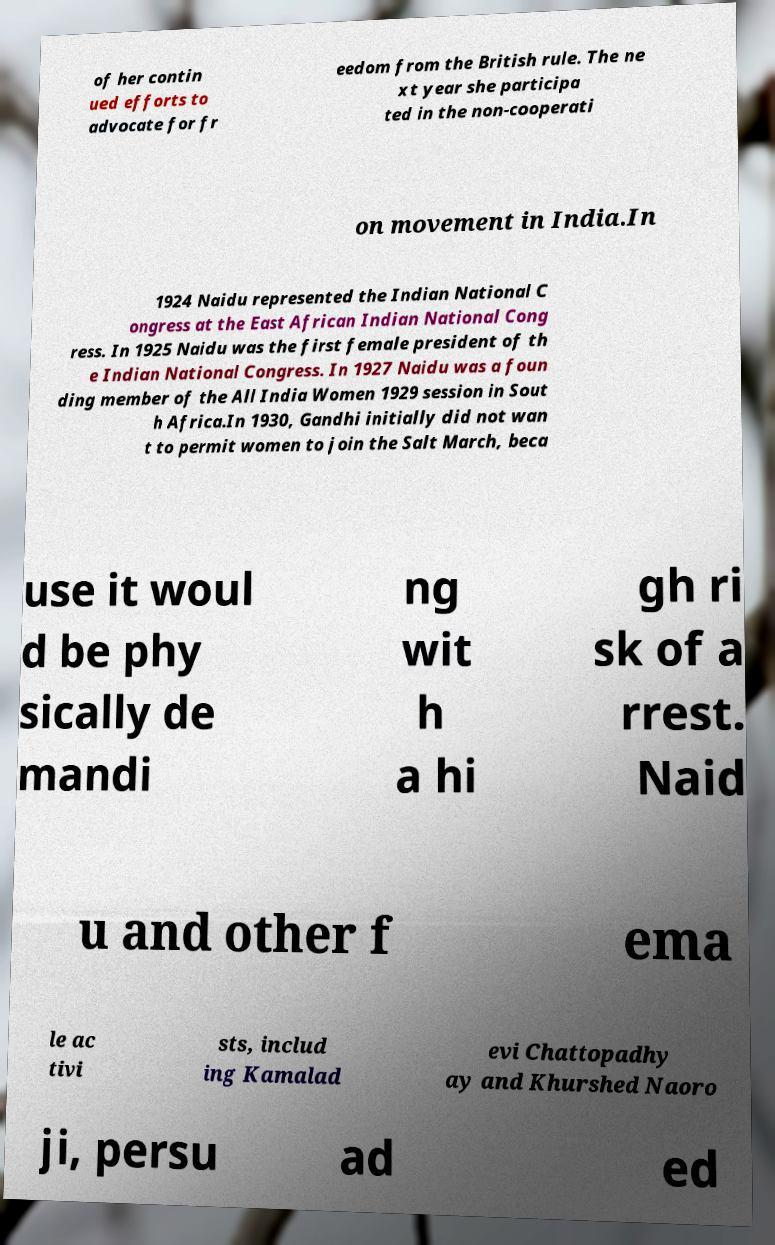There's text embedded in this image that I need extracted. Can you transcribe it verbatim? of her contin ued efforts to advocate for fr eedom from the British rule. The ne xt year she participa ted in the non-cooperati on movement in India.In 1924 Naidu represented the Indian National C ongress at the East African Indian National Cong ress. In 1925 Naidu was the first female president of th e Indian National Congress. In 1927 Naidu was a foun ding member of the All India Women 1929 session in Sout h Africa.In 1930, Gandhi initially did not wan t to permit women to join the Salt March, beca use it woul d be phy sically de mandi ng wit h a hi gh ri sk of a rrest. Naid u and other f ema le ac tivi sts, includ ing Kamalad evi Chattopadhy ay and Khurshed Naoro ji, persu ad ed 